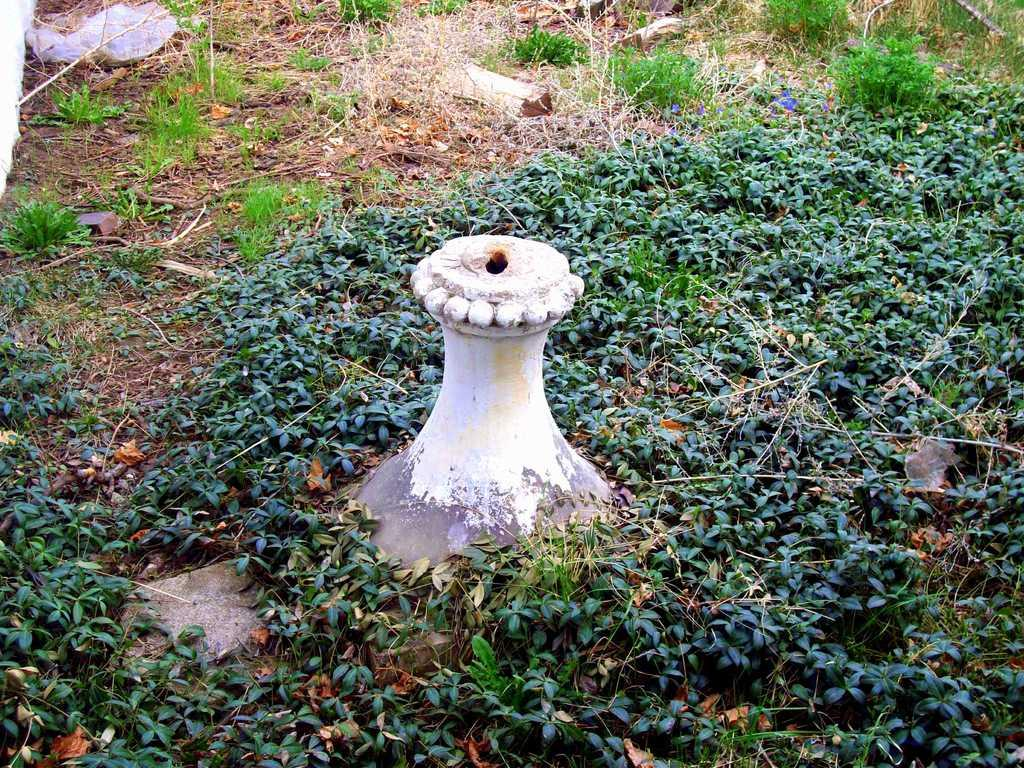What type of vegetation is visible on the ground in the image? There is grass on the ground in the image. What type of print can be seen on the back of the animal in the image? There is no animal or print present in the image; it only features grass on the ground. 